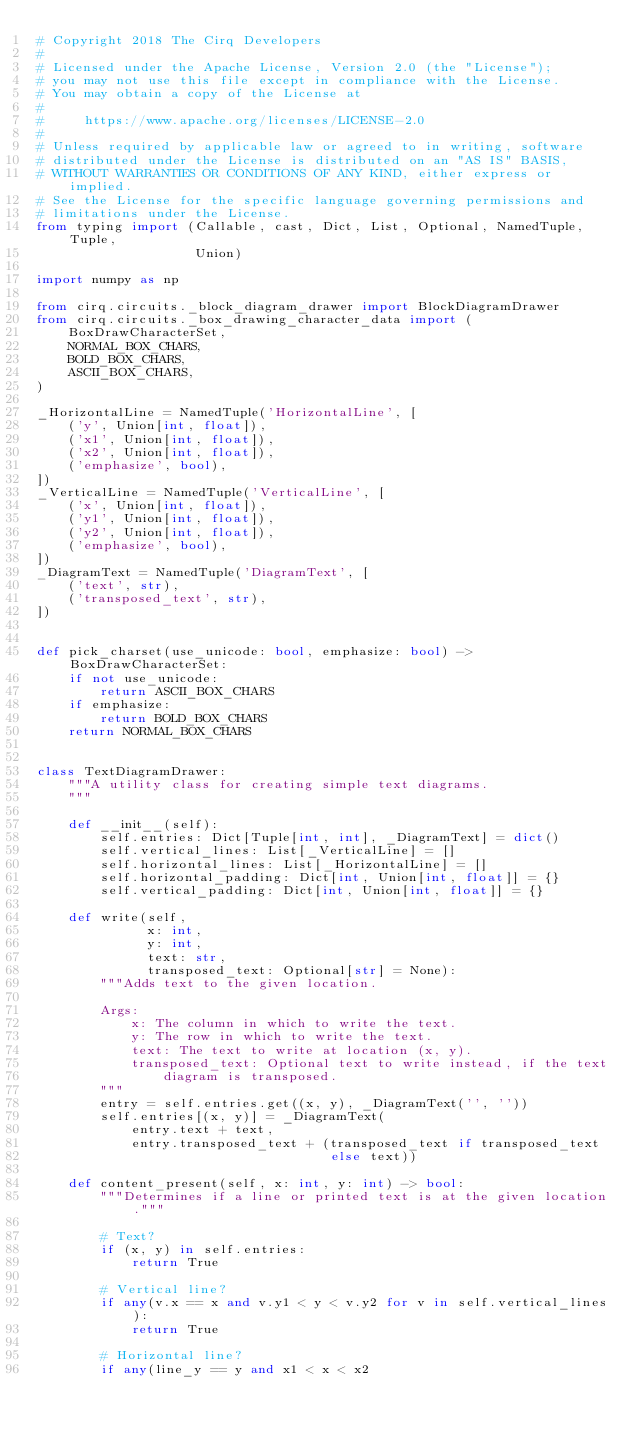Convert code to text. <code><loc_0><loc_0><loc_500><loc_500><_Python_># Copyright 2018 The Cirq Developers
#
# Licensed under the Apache License, Version 2.0 (the "License");
# you may not use this file except in compliance with the License.
# You may obtain a copy of the License at
#
#     https://www.apache.org/licenses/LICENSE-2.0
#
# Unless required by applicable law or agreed to in writing, software
# distributed under the License is distributed on an "AS IS" BASIS,
# WITHOUT WARRANTIES OR CONDITIONS OF ANY KIND, either express or implied.
# See the License for the specific language governing permissions and
# limitations under the License.
from typing import (Callable, cast, Dict, List, Optional, NamedTuple, Tuple,
                    Union)

import numpy as np

from cirq.circuits._block_diagram_drawer import BlockDiagramDrawer
from cirq.circuits._box_drawing_character_data import (
    BoxDrawCharacterSet,
    NORMAL_BOX_CHARS,
    BOLD_BOX_CHARS,
    ASCII_BOX_CHARS,
)

_HorizontalLine = NamedTuple('HorizontalLine', [
    ('y', Union[int, float]),
    ('x1', Union[int, float]),
    ('x2', Union[int, float]),
    ('emphasize', bool),
])
_VerticalLine = NamedTuple('VerticalLine', [
    ('x', Union[int, float]),
    ('y1', Union[int, float]),
    ('y2', Union[int, float]),
    ('emphasize', bool),
])
_DiagramText = NamedTuple('DiagramText', [
    ('text', str),
    ('transposed_text', str),
])


def pick_charset(use_unicode: bool, emphasize: bool) -> BoxDrawCharacterSet:
    if not use_unicode:
        return ASCII_BOX_CHARS
    if emphasize:
        return BOLD_BOX_CHARS
    return NORMAL_BOX_CHARS


class TextDiagramDrawer:
    """A utility class for creating simple text diagrams.
    """

    def __init__(self):
        self.entries: Dict[Tuple[int, int], _DiagramText] = dict()
        self.vertical_lines: List[_VerticalLine] = []
        self.horizontal_lines: List[_HorizontalLine] = []
        self.horizontal_padding: Dict[int, Union[int, float]] = {}
        self.vertical_padding: Dict[int, Union[int, float]] = {}

    def write(self,
              x: int,
              y: int,
              text: str,
              transposed_text: Optional[str] = None):
        """Adds text to the given location.

        Args:
            x: The column in which to write the text.
            y: The row in which to write the text.
            text: The text to write at location (x, y).
            transposed_text: Optional text to write instead, if the text
                diagram is transposed.
        """
        entry = self.entries.get((x, y), _DiagramText('', ''))
        self.entries[(x, y)] = _DiagramText(
            entry.text + text,
            entry.transposed_text + (transposed_text if transposed_text
                                     else text))

    def content_present(self, x: int, y: int) -> bool:
        """Determines if a line or printed text is at the given location."""

        # Text?
        if (x, y) in self.entries:
            return True

        # Vertical line?
        if any(v.x == x and v.y1 < y < v.y2 for v in self.vertical_lines):
            return True

        # Horizontal line?
        if any(line_y == y and x1 < x < x2</code> 